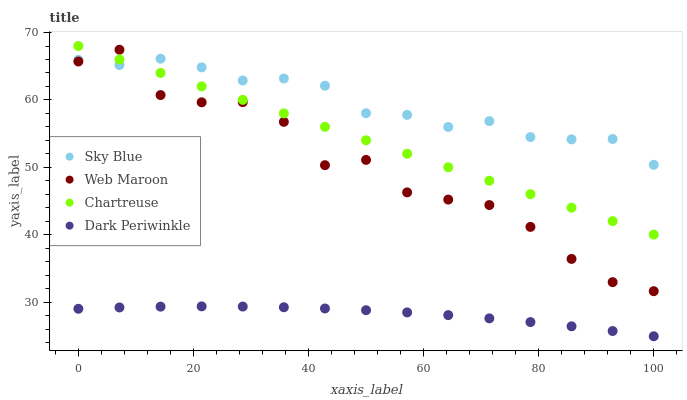Does Dark Periwinkle have the minimum area under the curve?
Answer yes or no. Yes. Does Sky Blue have the maximum area under the curve?
Answer yes or no. Yes. Does Chartreuse have the minimum area under the curve?
Answer yes or no. No. Does Chartreuse have the maximum area under the curve?
Answer yes or no. No. Is Chartreuse the smoothest?
Answer yes or no. Yes. Is Web Maroon the roughest?
Answer yes or no. Yes. Is Web Maroon the smoothest?
Answer yes or no. No. Is Chartreuse the roughest?
Answer yes or no. No. Does Dark Periwinkle have the lowest value?
Answer yes or no. Yes. Does Chartreuse have the lowest value?
Answer yes or no. No. Does Chartreuse have the highest value?
Answer yes or no. Yes. Does Web Maroon have the highest value?
Answer yes or no. No. Is Dark Periwinkle less than Chartreuse?
Answer yes or no. Yes. Is Web Maroon greater than Dark Periwinkle?
Answer yes or no. Yes. Does Web Maroon intersect Sky Blue?
Answer yes or no. Yes. Is Web Maroon less than Sky Blue?
Answer yes or no. No. Is Web Maroon greater than Sky Blue?
Answer yes or no. No. Does Dark Periwinkle intersect Chartreuse?
Answer yes or no. No. 